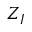<formula> <loc_0><loc_0><loc_500><loc_500>Z _ { I }</formula> 